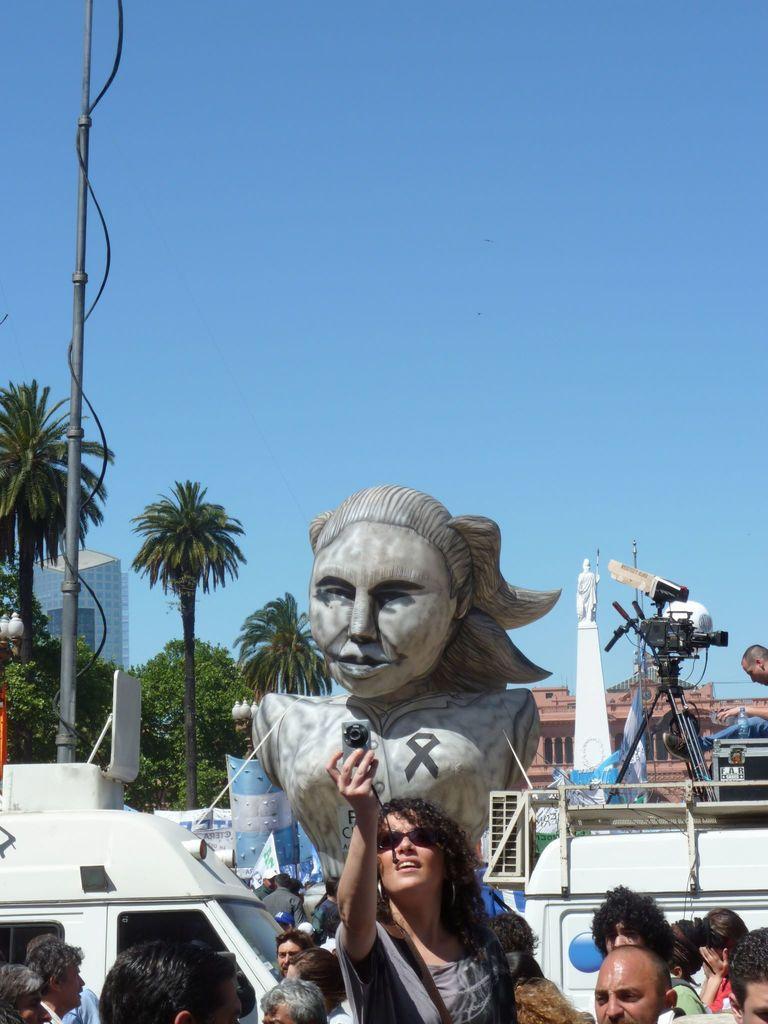Can you describe this image briefly? In this image we can see a statue, motor vehicle, persons standing on the road, woman holding a camera in her hands, buildings, trees, camera, tripods and sky. 